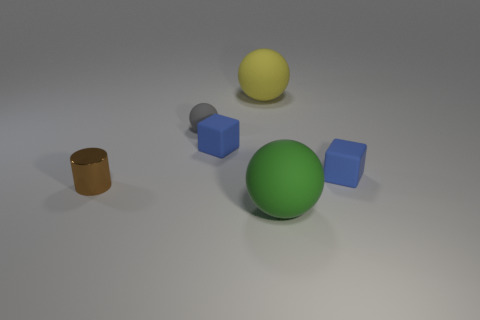Subtract all large spheres. How many spheres are left? 1 Subtract 1 blocks. How many blocks are left? 1 Add 3 big gray cylinders. How many objects exist? 9 Subtract all green balls. How many balls are left? 2 Subtract 0 red cylinders. How many objects are left? 6 Subtract all cylinders. How many objects are left? 5 Subtract all cyan balls. Subtract all yellow cylinders. How many balls are left? 3 Subtract all big green spheres. Subtract all small brown things. How many objects are left? 4 Add 4 tiny shiny cylinders. How many tiny shiny cylinders are left? 5 Add 6 big gray shiny cylinders. How many big gray shiny cylinders exist? 6 